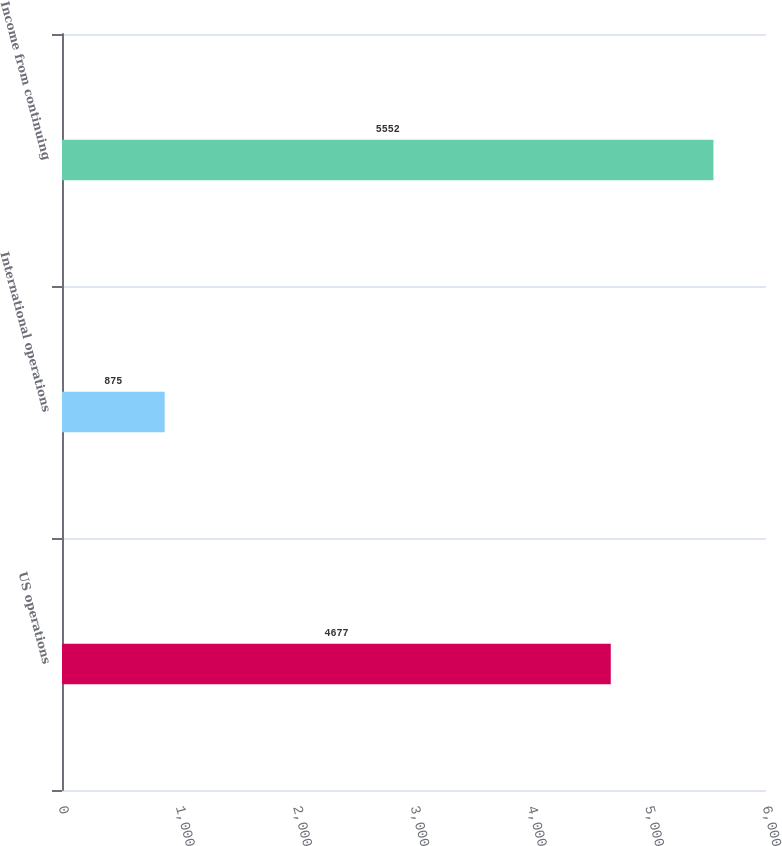Convert chart. <chart><loc_0><loc_0><loc_500><loc_500><bar_chart><fcel>US operations<fcel>International operations<fcel>Income from continuing<nl><fcel>4677<fcel>875<fcel>5552<nl></chart> 